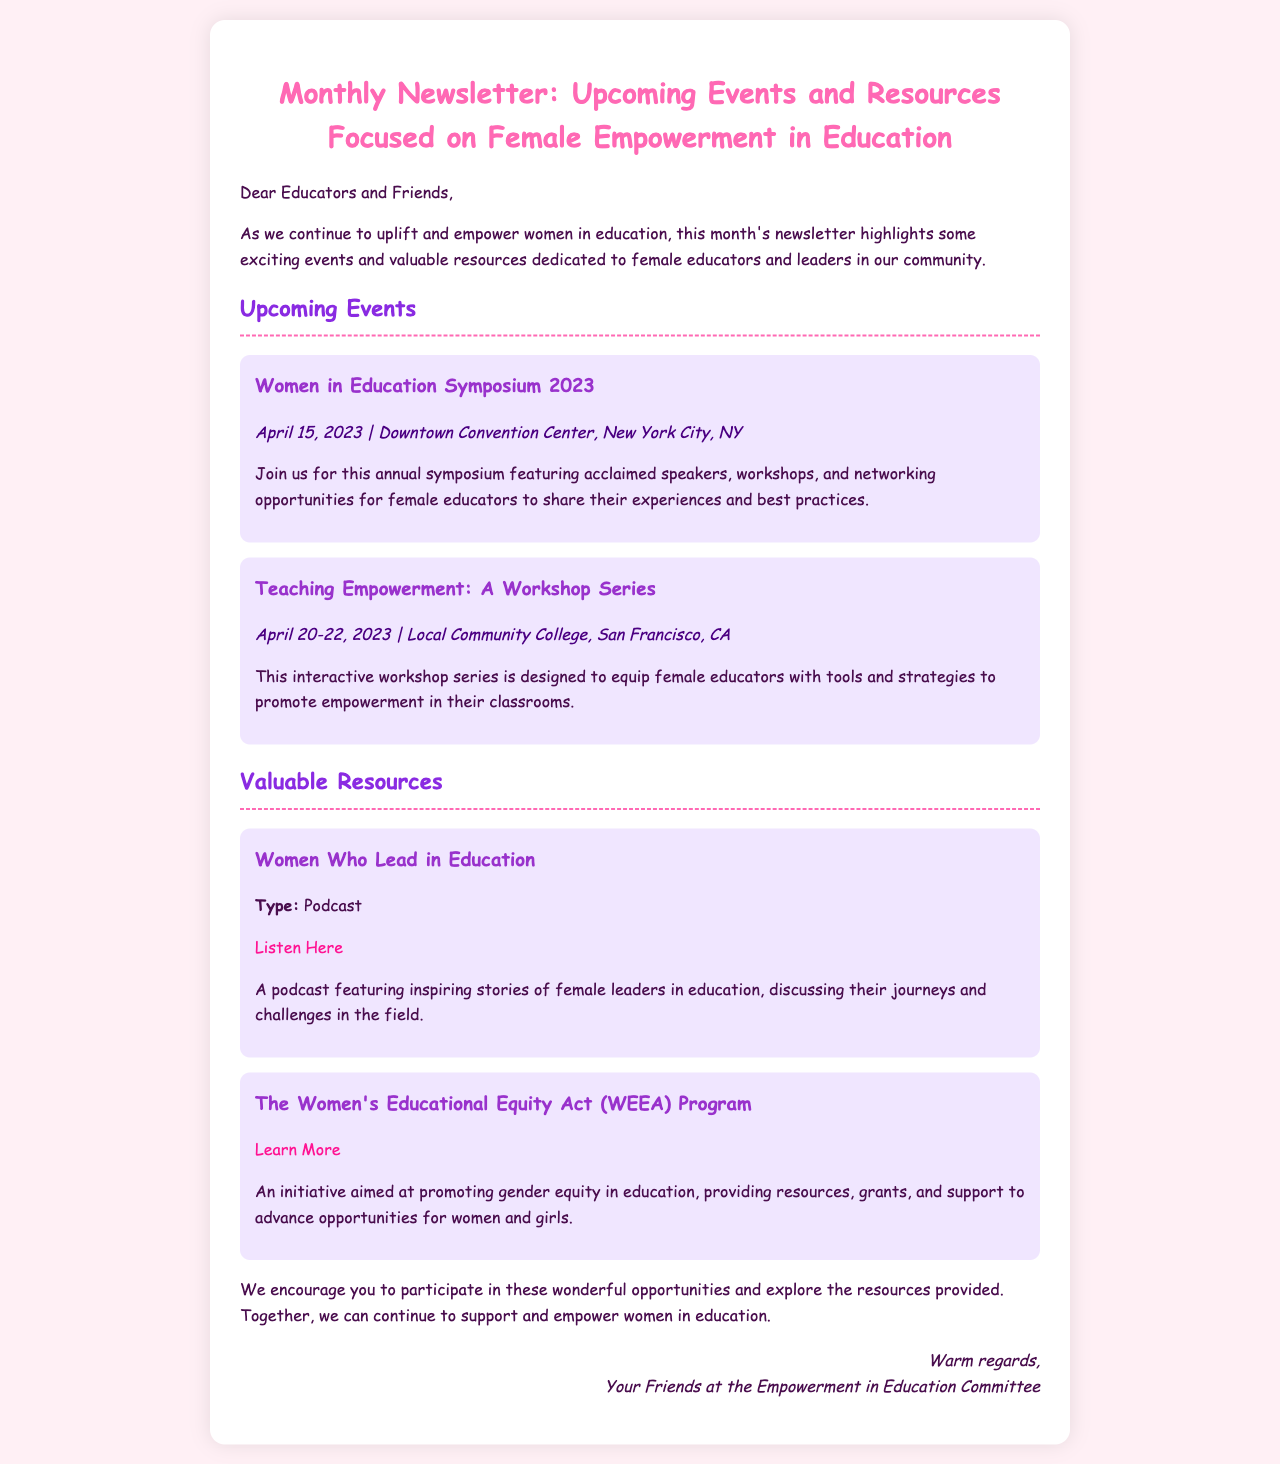What is the title of the newsletter? The title of the newsletter is mentioned at the top of the document, stating its purpose clearly.
Answer: Monthly Newsletter: Upcoming Events and Resources Focused on Female Empowerment in Education When is the Women in Education Symposium 2023 scheduled? The date of the symposium is specified in the events section of the newsletter.
Answer: April 15, 2023 Where is the Teaching Empowerment Workshop Series taking place? The location of the workshop series is provided under the events section of the newsletter.
Answer: Local Community College, San Francisco, CA What type of resource is "Women Who Lead in Education"? The type of the resource is explicitly mentioned in the resource section, indicating its format.
Answer: Podcast What is the goal of The Women's Educational Equity Act (WEEA) Program? The goal of the WEEA program is described in the context of promoting gender equity in education.
Answer: Promoting gender equity in education How many days is the Teaching Empowerment Workshop Series held? The duration of the workshop series is stated in the document, providing a clear timeframe.
Answer: 3 days What color is used for the event section? The background color used for the event section is highlighted in the styling of the newsletter.
Answer: #F0E6FF Who is the newsletter signed by? The signature at the end of the newsletter identifies the group involved.
Answer: Your Friends at the Empowerment in Education Committee 